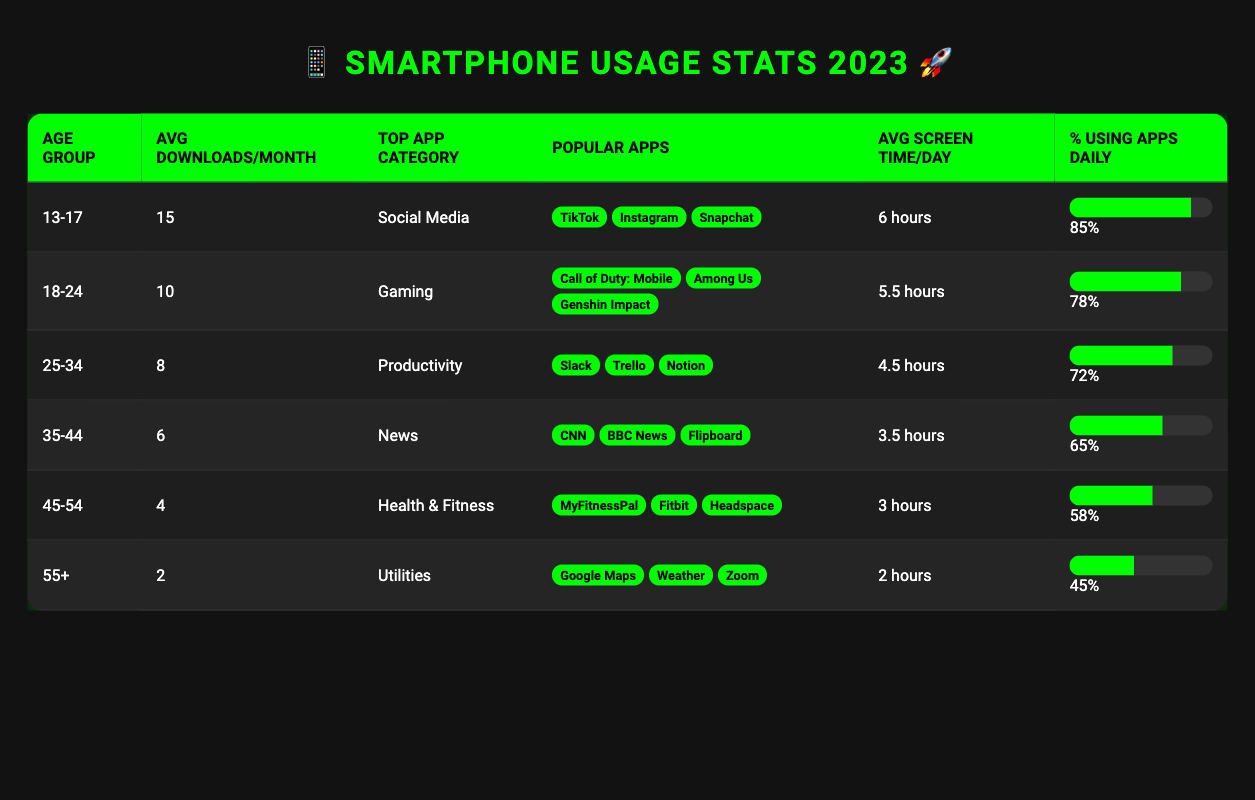What is the most popular app category among the 13-17 age group? The table states that the most popular app category for the 13-17 age group is "Social Media."
Answer: Social Media How many average downloads per month do people aged 25-34 have? According to the table, the average downloads per month for the 25-34 age group is 8.
Answer: 8 Is the percentage of daily app users higher for the 18-24 age group compared to the 35-44 age group? The percentage for the 18-24 age group is 78%, while for the 35-44 age group, it is 65%. Since 78% is greater than 65%, the statement is true.
Answer: Yes What is the difference in average screen time per day between the 45-54 age group and the 55+ age group? The 45-54 age group has an average screen time of 3 hours, and the 55+ age group has an average screen time of 2 hours. The difference is 3 - 2 = 1 hour.
Answer: 1 hour Which age group has the fewest average app downloads per month? The 55+ age group has the lowest average downloads per month at 2, which is less than all other age groups listed in the table.
Answer: 55+ What is the average number of downloads per month for all age groups combined? The average can be calculated by adding all monthly downloads: (15 + 10 + 8 + 6 + 4 + 2) = 45, then divide by 6 (the number of age groups), giving 45 / 6 = 7.5.
Answer: 7.5 Are the popular apps listed for the 35-44 age group particularly focused on gaming? The table mentions that the popular apps for the 35-44 age group are CNN, BBC News, and Flipboard, which are news-related, not gaming apps. Therefore, the statement is false.
Answer: No Which age group has the highest percentage of daily app users, and what is that percentage? The 13-17 age group has the highest percentage of daily app users at 85%, higher than any other age group.
Answer: 85% (13-17 age group) What are the popular apps in the 18-24 age group? The popular apps for the 18-24 age group according to the table are Call of Duty: Mobile, Among Us, and Genshin Impact.
Answer: Call of Duty: Mobile, Among Us, Genshin Impact 